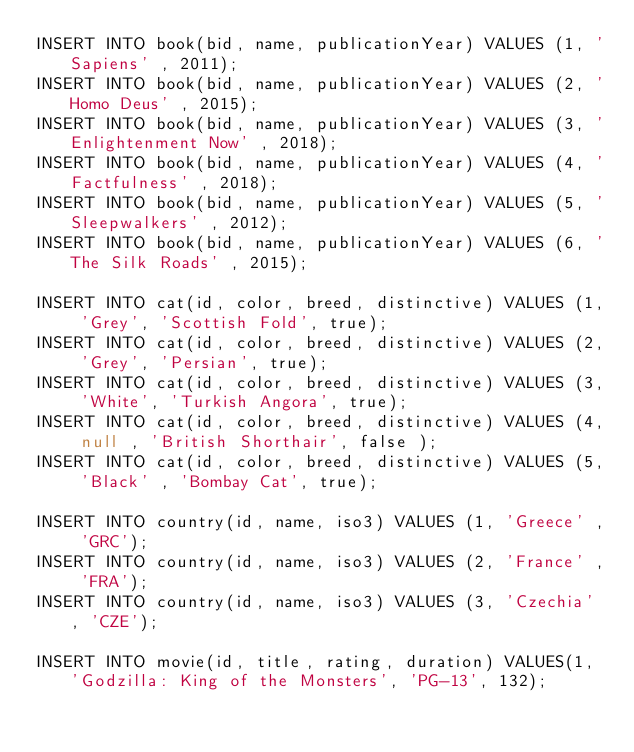<code> <loc_0><loc_0><loc_500><loc_500><_SQL_>INSERT INTO book(bid, name, publicationYear) VALUES (1, 'Sapiens' , 2011);
INSERT INTO book(bid, name, publicationYear) VALUES (2, 'Homo Deus' , 2015);
INSERT INTO book(bid, name, publicationYear) VALUES (3, 'Enlightenment Now' , 2018);
INSERT INTO book(bid, name, publicationYear) VALUES (4, 'Factfulness' , 2018);
INSERT INTO book(bid, name, publicationYear) VALUES (5, 'Sleepwalkers' , 2012);
INSERT INTO book(bid, name, publicationYear) VALUES (6, 'The Silk Roads' , 2015);

INSERT INTO cat(id, color, breed, distinctive) VALUES (1, 'Grey', 'Scottish Fold', true);
INSERT INTO cat(id, color, breed, distinctive) VALUES (2, 'Grey', 'Persian', true);
INSERT INTO cat(id, color, breed, distinctive) VALUES (3, 'White', 'Turkish Angora', true);
INSERT INTO cat(id, color, breed, distinctive) VALUES (4, null , 'British Shorthair', false );
INSERT INTO cat(id, color, breed, distinctive) VALUES (5, 'Black' , 'Bombay Cat', true);

INSERT INTO country(id, name, iso3) VALUES (1, 'Greece' , 'GRC');
INSERT INTO country(id, name, iso3) VALUES (2, 'France' , 'FRA');
INSERT INTO country(id, name, iso3) VALUES (3, 'Czechia' , 'CZE');

INSERT INTO movie(id, title, rating, duration) VALUES(1, 'Godzilla: King of the Monsters', 'PG-13', 132);</code> 